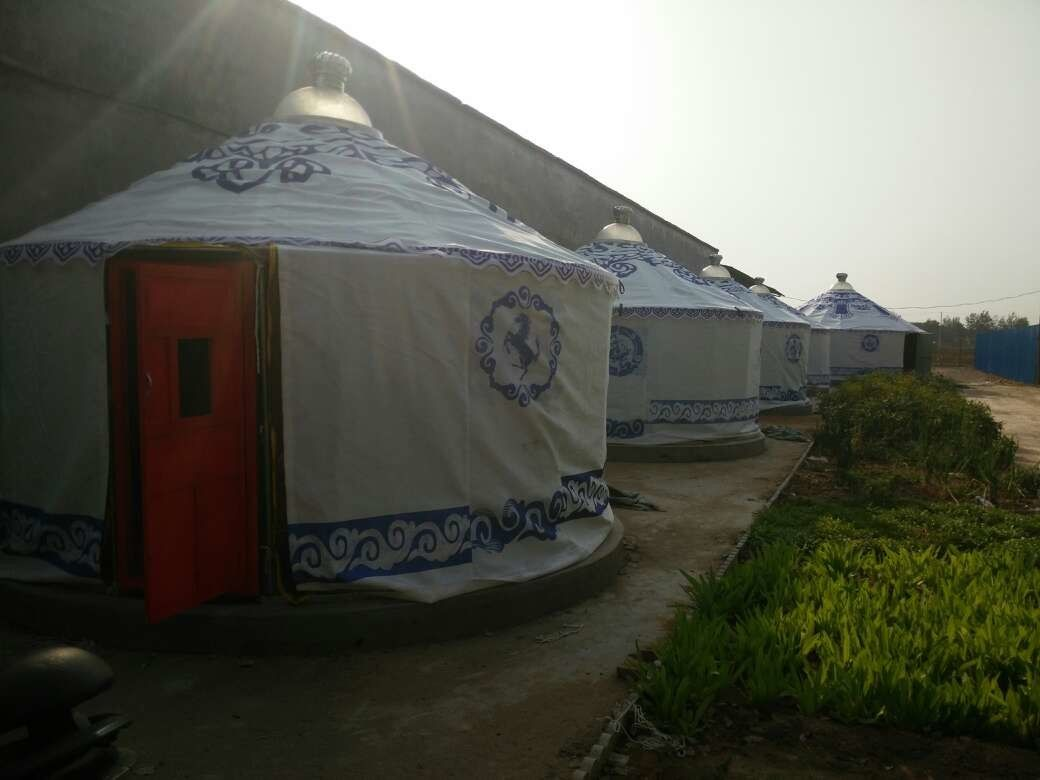Could you write a short story inspired by the scene in the image? Amidst the quiet whispers of the early morning mist, the yurts stood like silent guardians of tradition. Each yurt, with its intricate patterns, held the stories of countless generations. Dhaara, a young girl from the local village, wandered through the site, her imagination dancing with the tales her grandmother had told her. She imagined brave warriors planning their next journey, children herding sheep and goats, and women weaving tales of their ancestors into the fabric of their lives. Dhaara felt a deep connection to these ancient structures, a bridge between the past and her present. As the first rays of sunlight kissed the tops of the yurts, Dhaara vowed to preserve and share the rich heritage they represented, ensuring that the stories of her people would live on through future generations. Modern technology can significantly enhance the experience of attending a cultural event in this setting. Augmented Reality (AR) and Virtual Reality (VR) can provide immersive storytelling, allowing visitors to experience historical events, traditional ceremonies, or even daily life of the past as if they were there. Interactive apps can offer detailed information about each yurt, the traditions associated with it, and mini-games or activities related to the culture. Drone footage can capture stunning aerial views of the event, giving a broader perspective of the setting. Live streaming and social media integration ensure that even those who cannot physically attend can experience and engage with the event in real-time. QR codes placed around the site can lead to multimedia content, including interviews, music, and dance performances, further deepening visitors' understanding and appreciation. These technologies, combined with the authentic yurt experience, create a rich, multi-layered cultural immersion. 